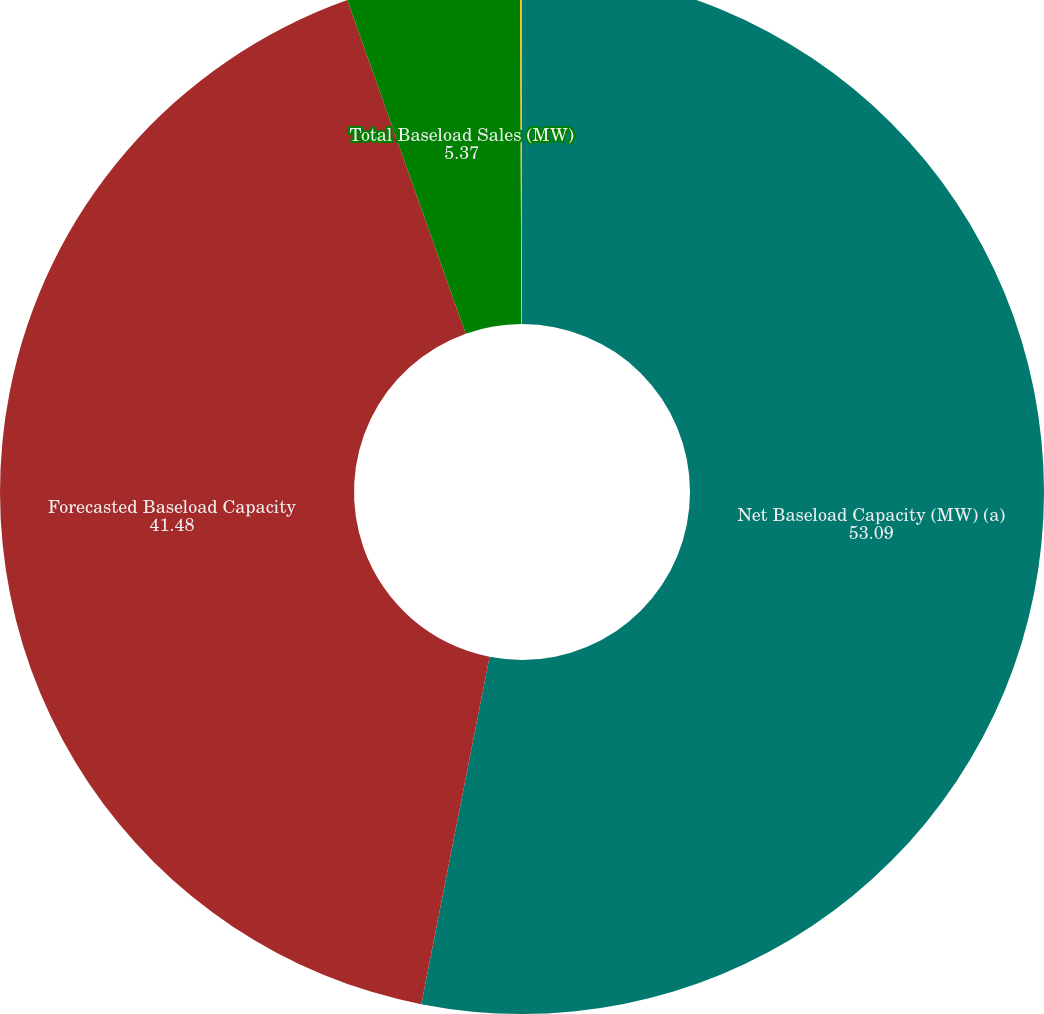Convert chart. <chart><loc_0><loc_0><loc_500><loc_500><pie_chart><fcel>Net Baseload Capacity (MW) (a)<fcel>Forecasted Baseload Capacity<fcel>Total Baseload Sales (MW)<fcel>Percentage Baseload Capacity<nl><fcel>53.09%<fcel>41.48%<fcel>5.37%<fcel>0.06%<nl></chart> 